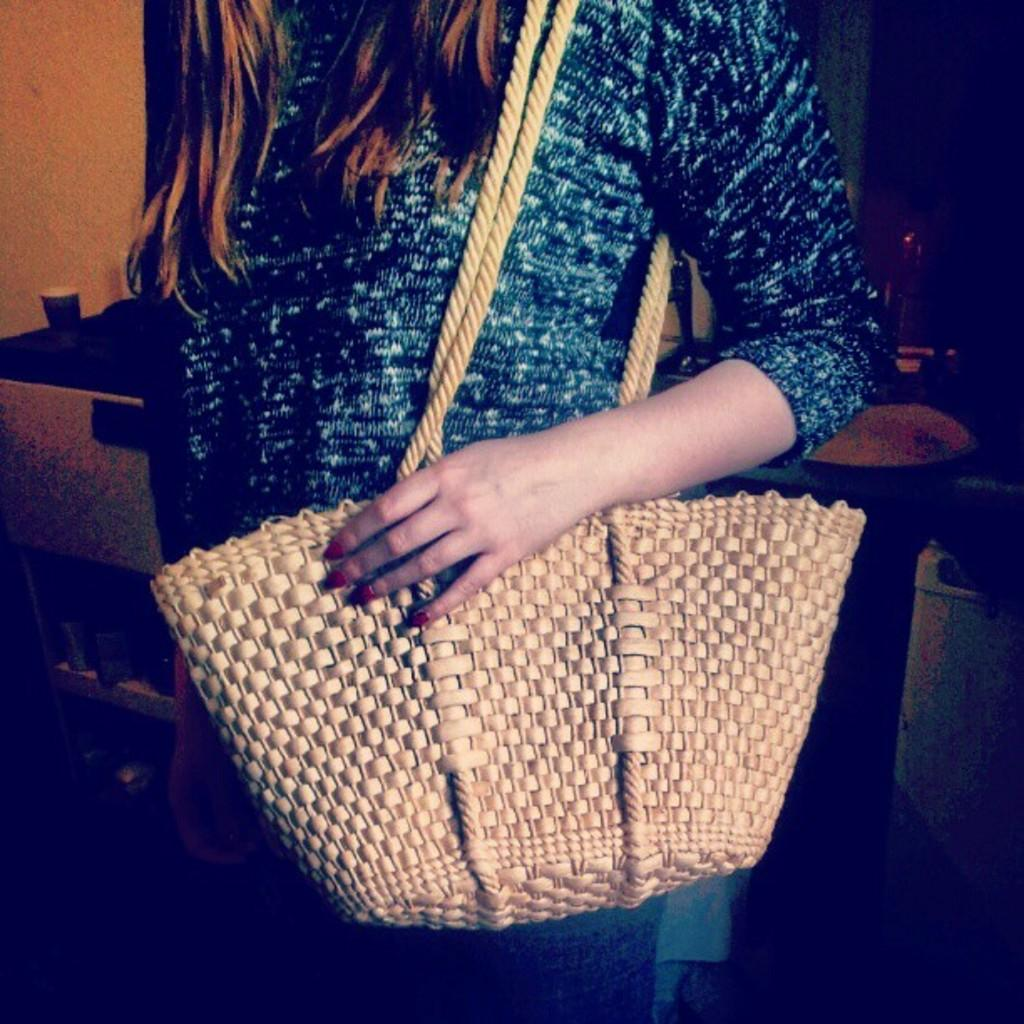What is the woman in the image carrying? The woman is carrying a bag. What type of furniture can be seen in the image? There are chairs and a table in the image. What grade does the bee receive in the image? There is no bee present in the image, so it cannot receive a grade. 